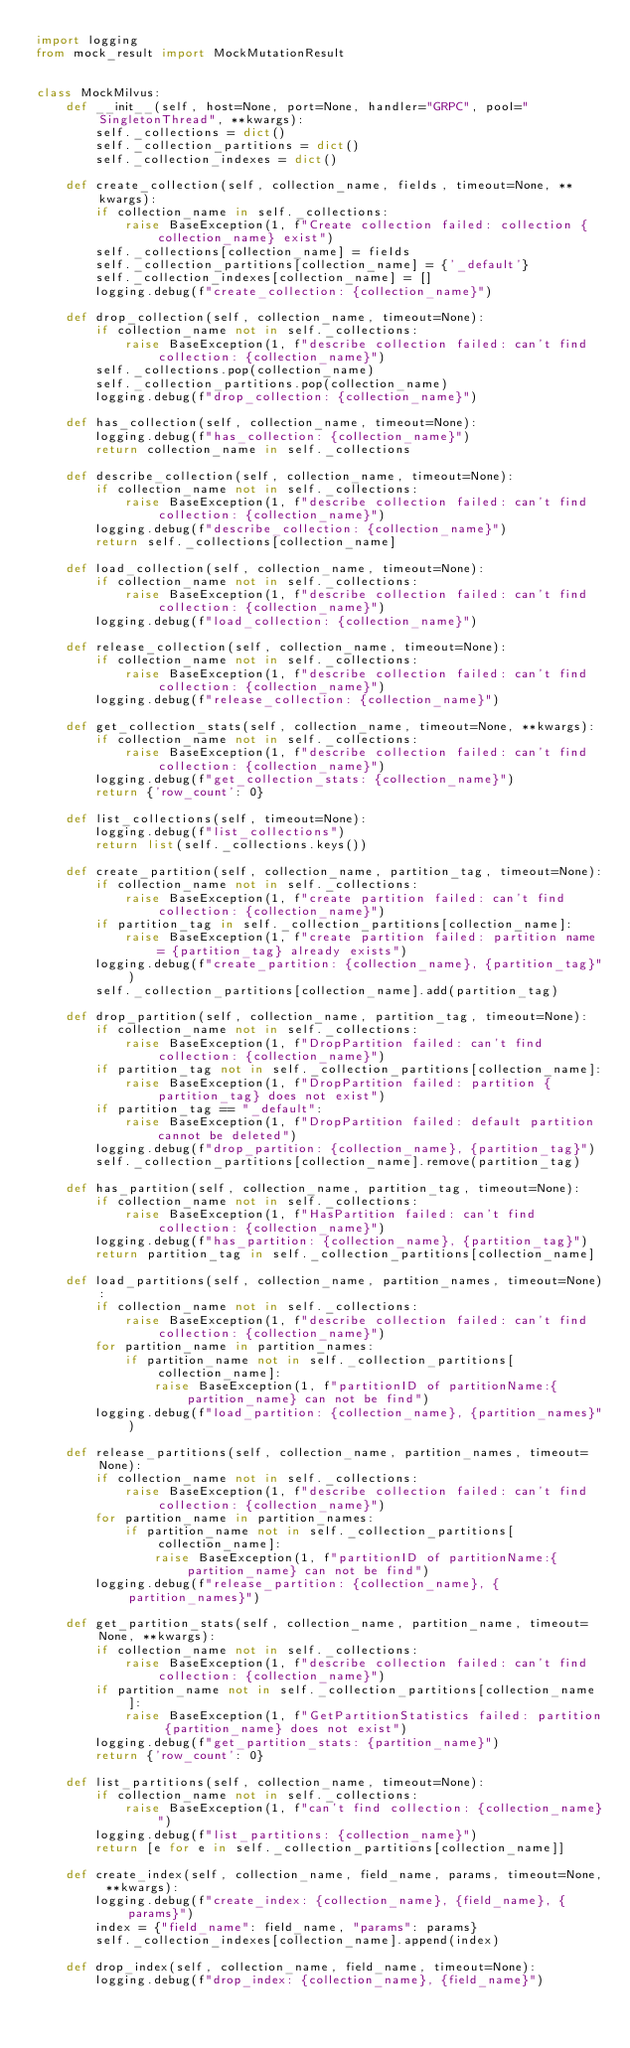<code> <loc_0><loc_0><loc_500><loc_500><_Python_>import logging
from mock_result import MockMutationResult


class MockMilvus:
    def __init__(self, host=None, port=None, handler="GRPC", pool="SingletonThread", **kwargs):
        self._collections = dict()
        self._collection_partitions = dict()
        self._collection_indexes = dict()

    def create_collection(self, collection_name, fields, timeout=None, **kwargs):
        if collection_name in self._collections:
            raise BaseException(1, f"Create collection failed: collection {collection_name} exist")
        self._collections[collection_name] = fields
        self._collection_partitions[collection_name] = {'_default'}
        self._collection_indexes[collection_name] = []
        logging.debug(f"create_collection: {collection_name}")

    def drop_collection(self, collection_name, timeout=None):
        if collection_name not in self._collections:
            raise BaseException(1, f"describe collection failed: can't find collection: {collection_name}")
        self._collections.pop(collection_name)
        self._collection_partitions.pop(collection_name)
        logging.debug(f"drop_collection: {collection_name}")

    def has_collection(self, collection_name, timeout=None):
        logging.debug(f"has_collection: {collection_name}")
        return collection_name in self._collections

    def describe_collection(self, collection_name, timeout=None):
        if collection_name not in self._collections:
            raise BaseException(1, f"describe collection failed: can't find collection: {collection_name}")
        logging.debug(f"describe_collection: {collection_name}")
        return self._collections[collection_name]

    def load_collection(self, collection_name, timeout=None):
        if collection_name not in self._collections:
            raise BaseException(1, f"describe collection failed: can't find collection: {collection_name}")
        logging.debug(f"load_collection: {collection_name}")

    def release_collection(self, collection_name, timeout=None):
        if collection_name not in self._collections:
            raise BaseException(1, f"describe collection failed: can't find collection: {collection_name}")
        logging.debug(f"release_collection: {collection_name}")

    def get_collection_stats(self, collection_name, timeout=None, **kwargs):
        if collection_name not in self._collections:
            raise BaseException(1, f"describe collection failed: can't find collection: {collection_name}")
        logging.debug(f"get_collection_stats: {collection_name}")
        return {'row_count': 0}

    def list_collections(self, timeout=None):
        logging.debug(f"list_collections")
        return list(self._collections.keys())

    def create_partition(self, collection_name, partition_tag, timeout=None):
        if collection_name not in self._collections:
            raise BaseException(1, f"create partition failed: can't find collection: {collection_name}")
        if partition_tag in self._collection_partitions[collection_name]:
            raise BaseException(1, f"create partition failed: partition name = {partition_tag} already exists")
        logging.debug(f"create_partition: {collection_name}, {partition_tag}")
        self._collection_partitions[collection_name].add(partition_tag)

    def drop_partition(self, collection_name, partition_tag, timeout=None):
        if collection_name not in self._collections:
            raise BaseException(1, f"DropPartition failed: can't find collection: {collection_name}")
        if partition_tag not in self._collection_partitions[collection_name]:
            raise BaseException(1, f"DropPartition failed: partition {partition_tag} does not exist")
        if partition_tag == "_default":
            raise BaseException(1, f"DropPartition failed: default partition cannot be deleted")
        logging.debug(f"drop_partition: {collection_name}, {partition_tag}")
        self._collection_partitions[collection_name].remove(partition_tag)

    def has_partition(self, collection_name, partition_tag, timeout=None):
        if collection_name not in self._collections:
            raise BaseException(1, f"HasPartition failed: can't find collection: {collection_name}")
        logging.debug(f"has_partition: {collection_name}, {partition_tag}")
        return partition_tag in self._collection_partitions[collection_name]

    def load_partitions(self, collection_name, partition_names, timeout=None):
        if collection_name not in self._collections:
            raise BaseException(1, f"describe collection failed: can't find collection: {collection_name}")
        for partition_name in partition_names:
            if partition_name not in self._collection_partitions[collection_name]:
                raise BaseException(1, f"partitionID of partitionName:{partition_name} can not be find")
        logging.debug(f"load_partition: {collection_name}, {partition_names}")

    def release_partitions(self, collection_name, partition_names, timeout=None):
        if collection_name not in self._collections:
            raise BaseException(1, f"describe collection failed: can't find collection: {collection_name}")
        for partition_name in partition_names:
            if partition_name not in self._collection_partitions[collection_name]:
                raise BaseException(1, f"partitionID of partitionName:{partition_name} can not be find")
        logging.debug(f"release_partition: {collection_name}, {partition_names}")

    def get_partition_stats(self, collection_name, partition_name, timeout=None, **kwargs):
        if collection_name not in self._collections:
            raise BaseException(1, f"describe collection failed: can't find collection: {collection_name}")
        if partition_name not in self._collection_partitions[collection_name]:
            raise BaseException(1, f"GetPartitionStatistics failed: partition {partition_name} does not exist")
        logging.debug(f"get_partition_stats: {partition_name}")
        return {'row_count': 0}

    def list_partitions(self, collection_name, timeout=None):
        if collection_name not in self._collections:
            raise BaseException(1, f"can't find collection: {collection_name}")
        logging.debug(f"list_partitions: {collection_name}")
        return [e for e in self._collection_partitions[collection_name]]

    def create_index(self, collection_name, field_name, params, timeout=None, **kwargs):
        logging.debug(f"create_index: {collection_name}, {field_name}, {params}")
        index = {"field_name": field_name, "params": params}
        self._collection_indexes[collection_name].append(index)

    def drop_index(self, collection_name, field_name, timeout=None):
        logging.debug(f"drop_index: {collection_name}, {field_name}")</code> 